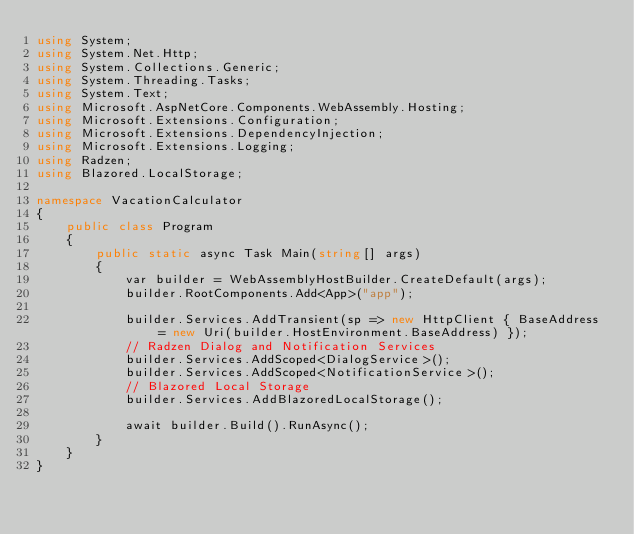Convert code to text. <code><loc_0><loc_0><loc_500><loc_500><_C#_>using System;
using System.Net.Http;
using System.Collections.Generic;
using System.Threading.Tasks;
using System.Text;
using Microsoft.AspNetCore.Components.WebAssembly.Hosting;
using Microsoft.Extensions.Configuration;
using Microsoft.Extensions.DependencyInjection;
using Microsoft.Extensions.Logging;
using Radzen;
using Blazored.LocalStorage;

namespace VacationCalculator
{
    public class Program
    {
        public static async Task Main(string[] args)
        {
            var builder = WebAssemblyHostBuilder.CreateDefault(args);
            builder.RootComponents.Add<App>("app");

            builder.Services.AddTransient(sp => new HttpClient { BaseAddress = new Uri(builder.HostEnvironment.BaseAddress) });
            // Radzen Dialog and Notification Services
            builder.Services.AddScoped<DialogService>();
            builder.Services.AddScoped<NotificationService>();
            // Blazored Local Storage
            builder.Services.AddBlazoredLocalStorage();

            await builder.Build().RunAsync();
        }
    }
}
</code> 